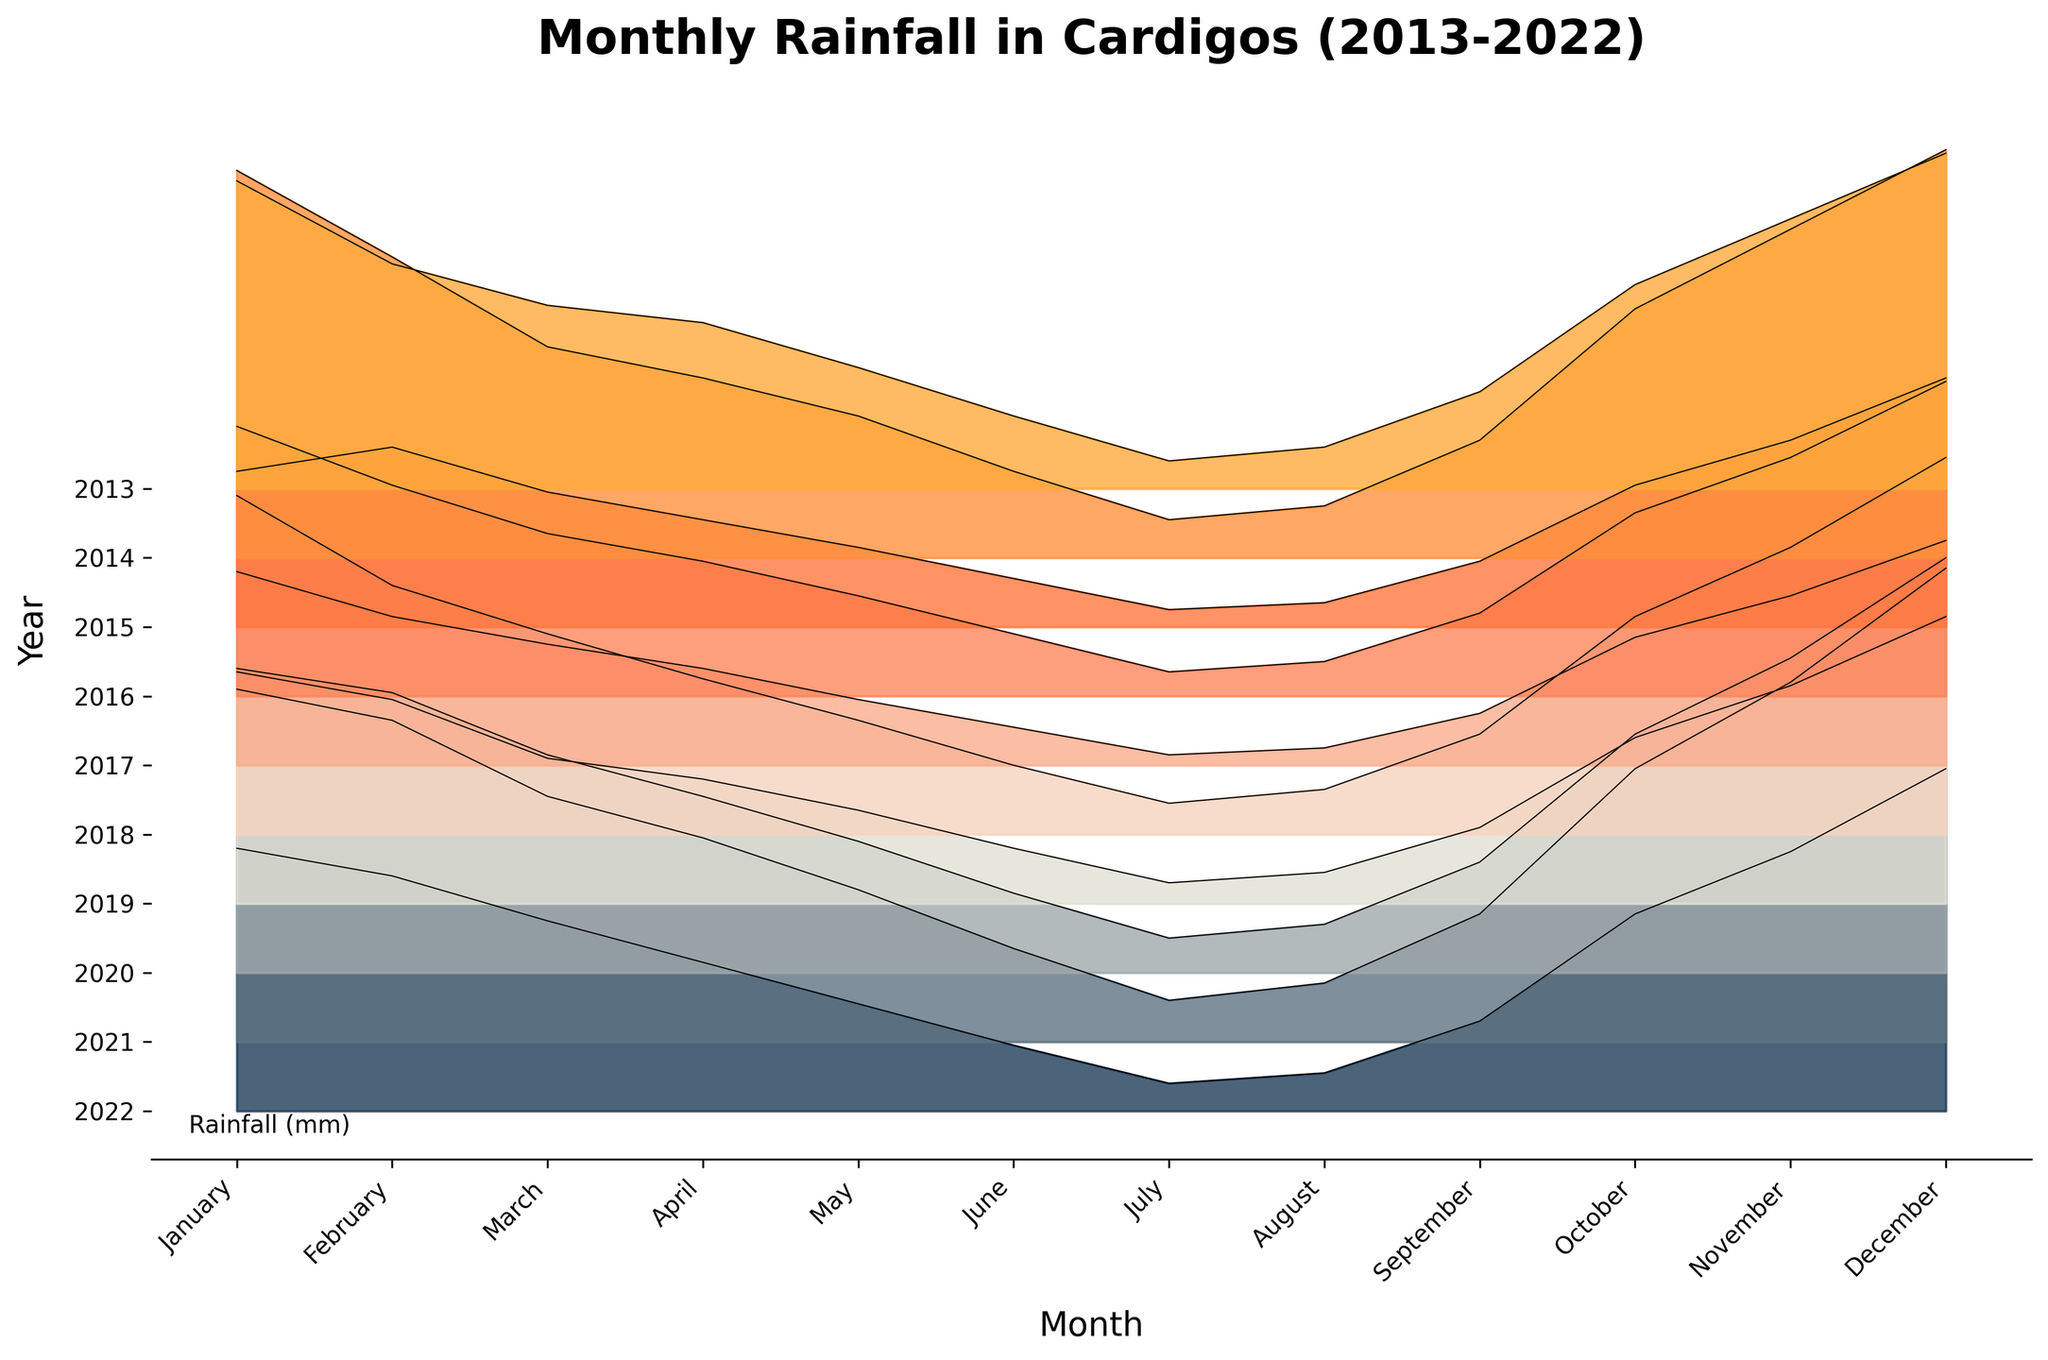What is the title of the plot? The title is located at the top center of the figure and is typically in a larger font size for visibility. It often gives an overview of what the plot represents.
Answer: Monthly Rainfall in Cardigos (2013-2022) Which month shows the highest rainfall in 2020? To find this, we look for the peak value for the year 2020 within the plot and then locate the corresponding month on the x-axis.
Answer: December In which year did Cardigos experience the lowest rainfall in July? Locate July on the x-axis, then trace each July's rainfall level across the years plotted on the y-axis. Find the lowest point over all years.
Answer: 2017 How does the total rainfall in November 2013 compare to November 2022? Identify the y-values for November in both 2013 and 2022 and compare these two values. Sum them for a more comprehensive understanding if needed. November 2022 shows more total rainfall than November 2013.
Answer: 75 mm more in 2022 What trend can be observed in the month of October over the years? Track the October values across the years by following the October tick along the x-axis and noting the changes in height of the October lines for each year.
Answer: Increasing trend How does the rainfall in January compare for the years 2013 and 2022? Compare the y-values for January in both 2013 and 2022.
Answer: Higher in 2014 In which month does 2021 show a significant increase in rainfall compared to 2020? Compare the y-values for each month of 2021 with the corresponding month of 2020 to identify where a significant increase is observed.
Answer: December What is the overall rainfall pattern like in June across the years? Observe the heights of the filled areas corresponding to June and track any rises or falls over the years plotted.
Answer: Generally constant, mostly low Which month shows the least variation in rainfall over the decade? Locate the months with the most consistent height across all years to identify which shows the least variation.
Answer: July 